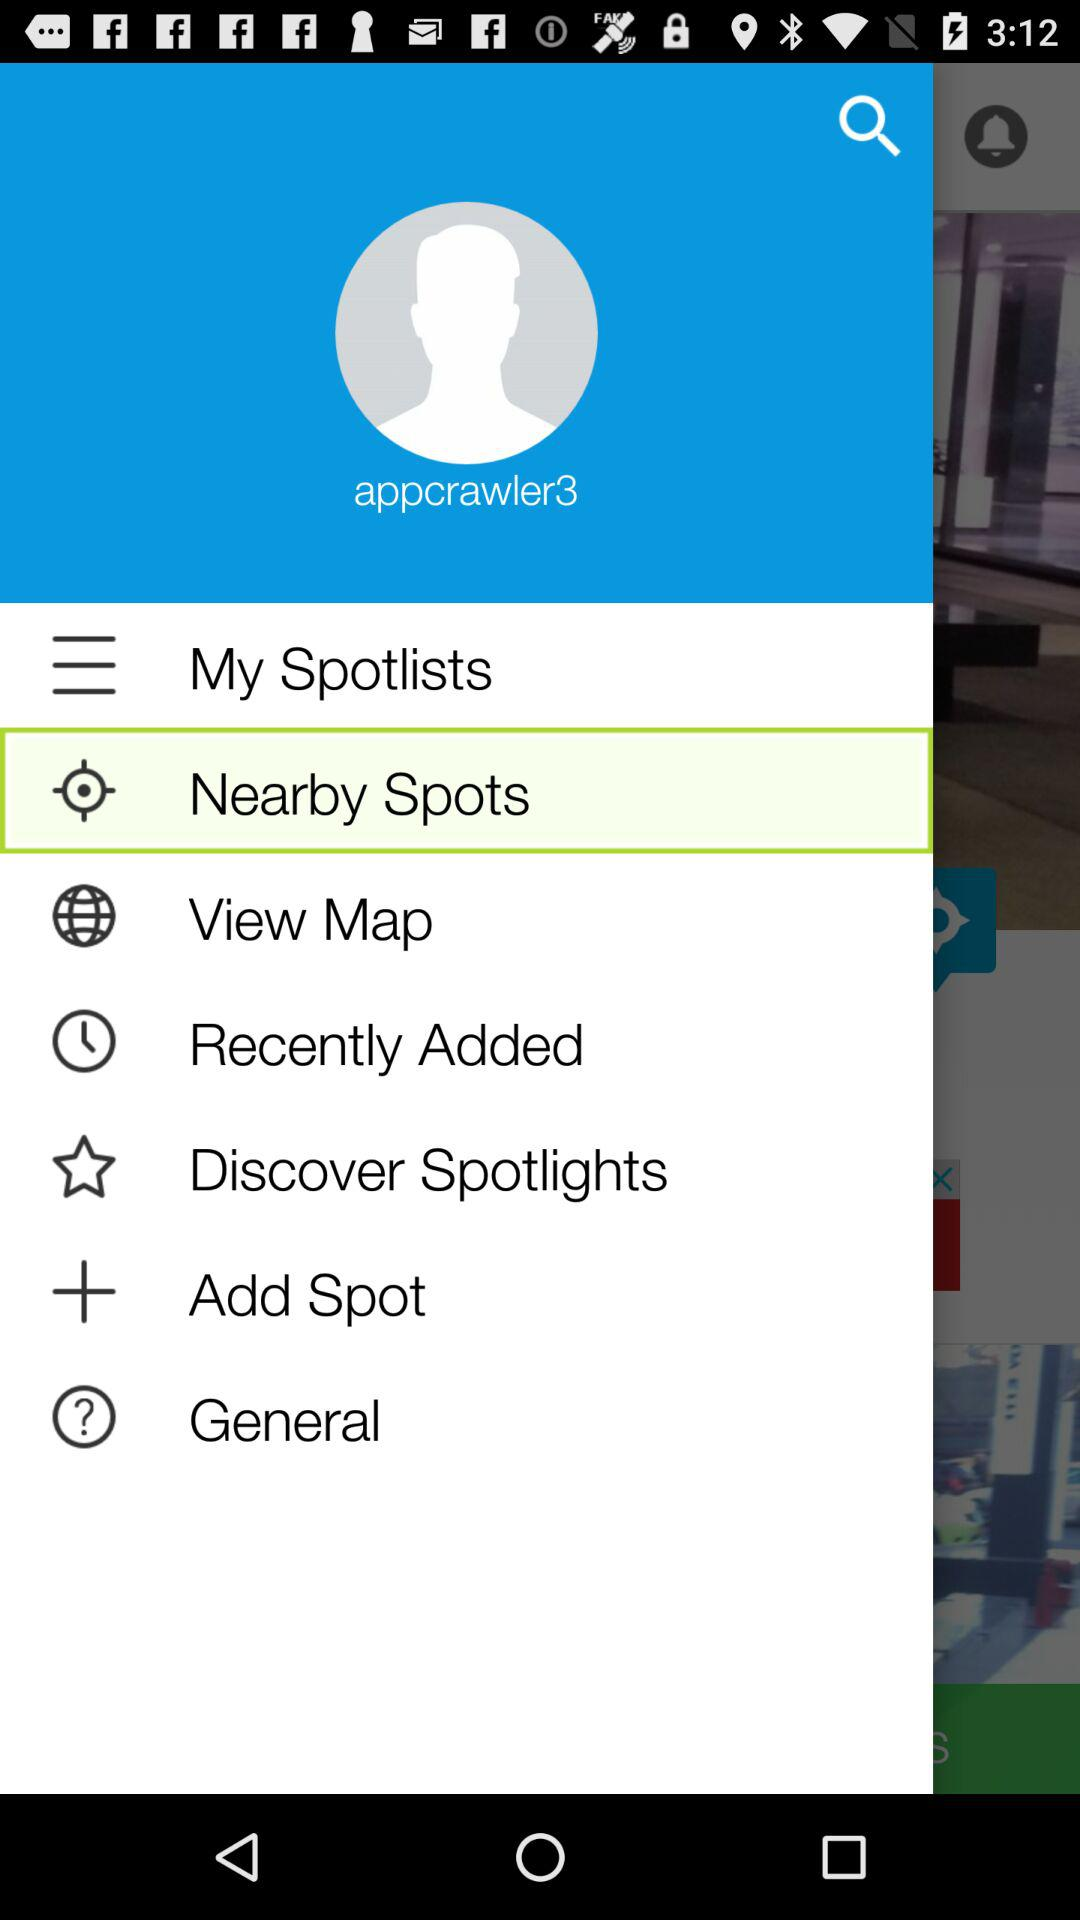What is the username? The username is "appcrawler3". 